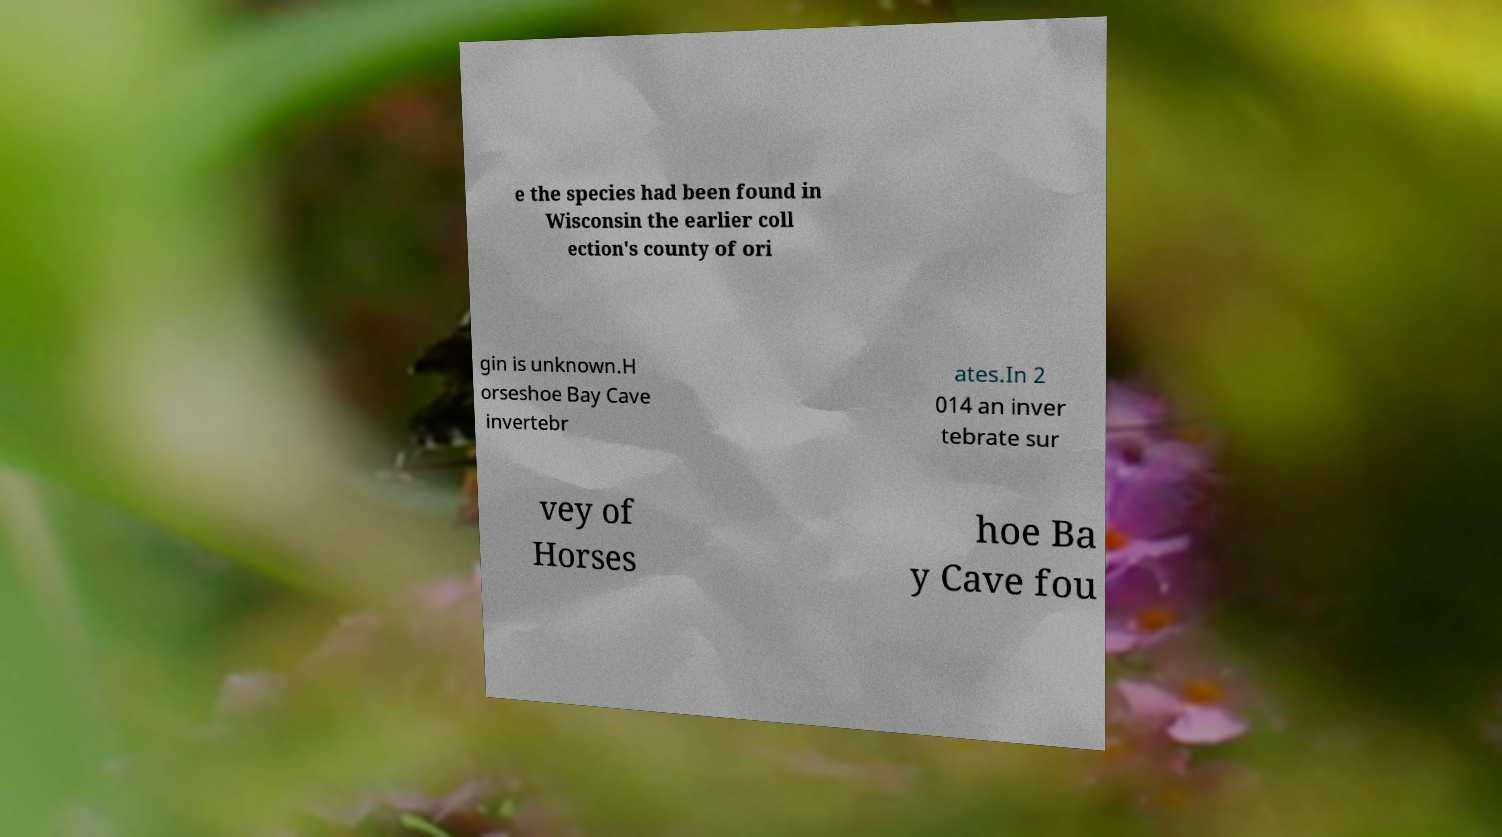For documentation purposes, I need the text within this image transcribed. Could you provide that? e the species had been found in Wisconsin the earlier coll ection's county of ori gin is unknown.H orseshoe Bay Cave invertebr ates.In 2 014 an inver tebrate sur vey of Horses hoe Ba y Cave fou 